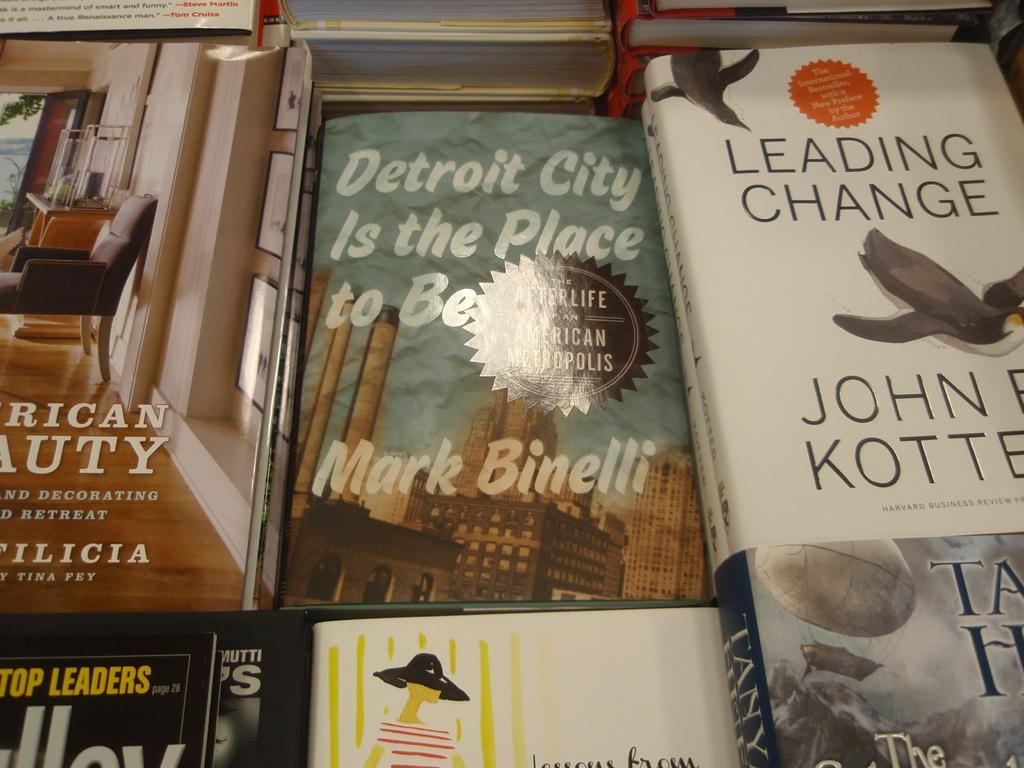<image>
Describe the image concisely. The white book with birds is titled Leading Change 